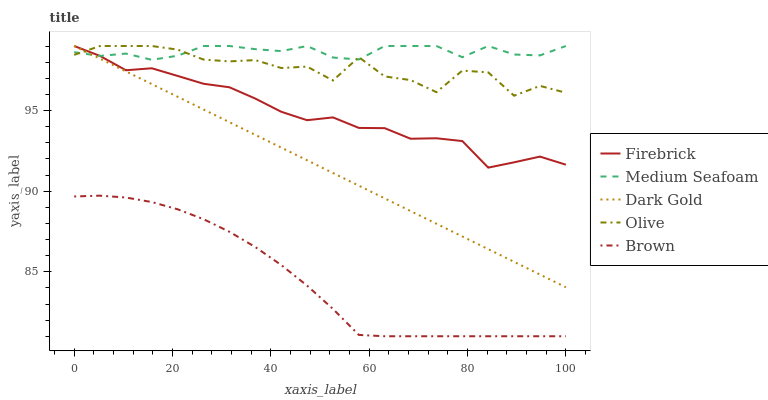Does Brown have the minimum area under the curve?
Answer yes or no. Yes. Does Medium Seafoam have the maximum area under the curve?
Answer yes or no. Yes. Does Firebrick have the minimum area under the curve?
Answer yes or no. No. Does Firebrick have the maximum area under the curve?
Answer yes or no. No. Is Dark Gold the smoothest?
Answer yes or no. Yes. Is Olive the roughest?
Answer yes or no. Yes. Is Brown the smoothest?
Answer yes or no. No. Is Brown the roughest?
Answer yes or no. No. Does Brown have the lowest value?
Answer yes or no. Yes. Does Firebrick have the lowest value?
Answer yes or no. No. Does Dark Gold have the highest value?
Answer yes or no. Yes. Does Brown have the highest value?
Answer yes or no. No. Is Brown less than Medium Seafoam?
Answer yes or no. Yes. Is Medium Seafoam greater than Brown?
Answer yes or no. Yes. Does Dark Gold intersect Olive?
Answer yes or no. Yes. Is Dark Gold less than Olive?
Answer yes or no. No. Is Dark Gold greater than Olive?
Answer yes or no. No. Does Brown intersect Medium Seafoam?
Answer yes or no. No. 